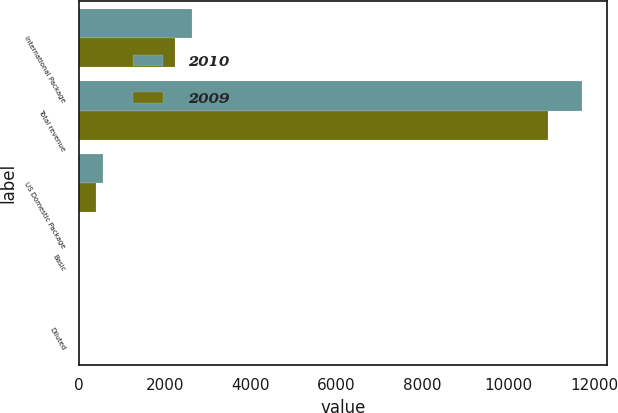<chart> <loc_0><loc_0><loc_500><loc_500><stacked_bar_chart><ecel><fcel>International Package<fcel>Total revenue<fcel>US Domestic Package<fcel>Basic<fcel>Diluted<nl><fcel>2010<fcel>2639<fcel>11728<fcel>562<fcel>0.54<fcel>0.53<nl><fcel>2009<fcel>2240<fcel>10938<fcel>384<fcel>0.4<fcel>0.4<nl></chart> 